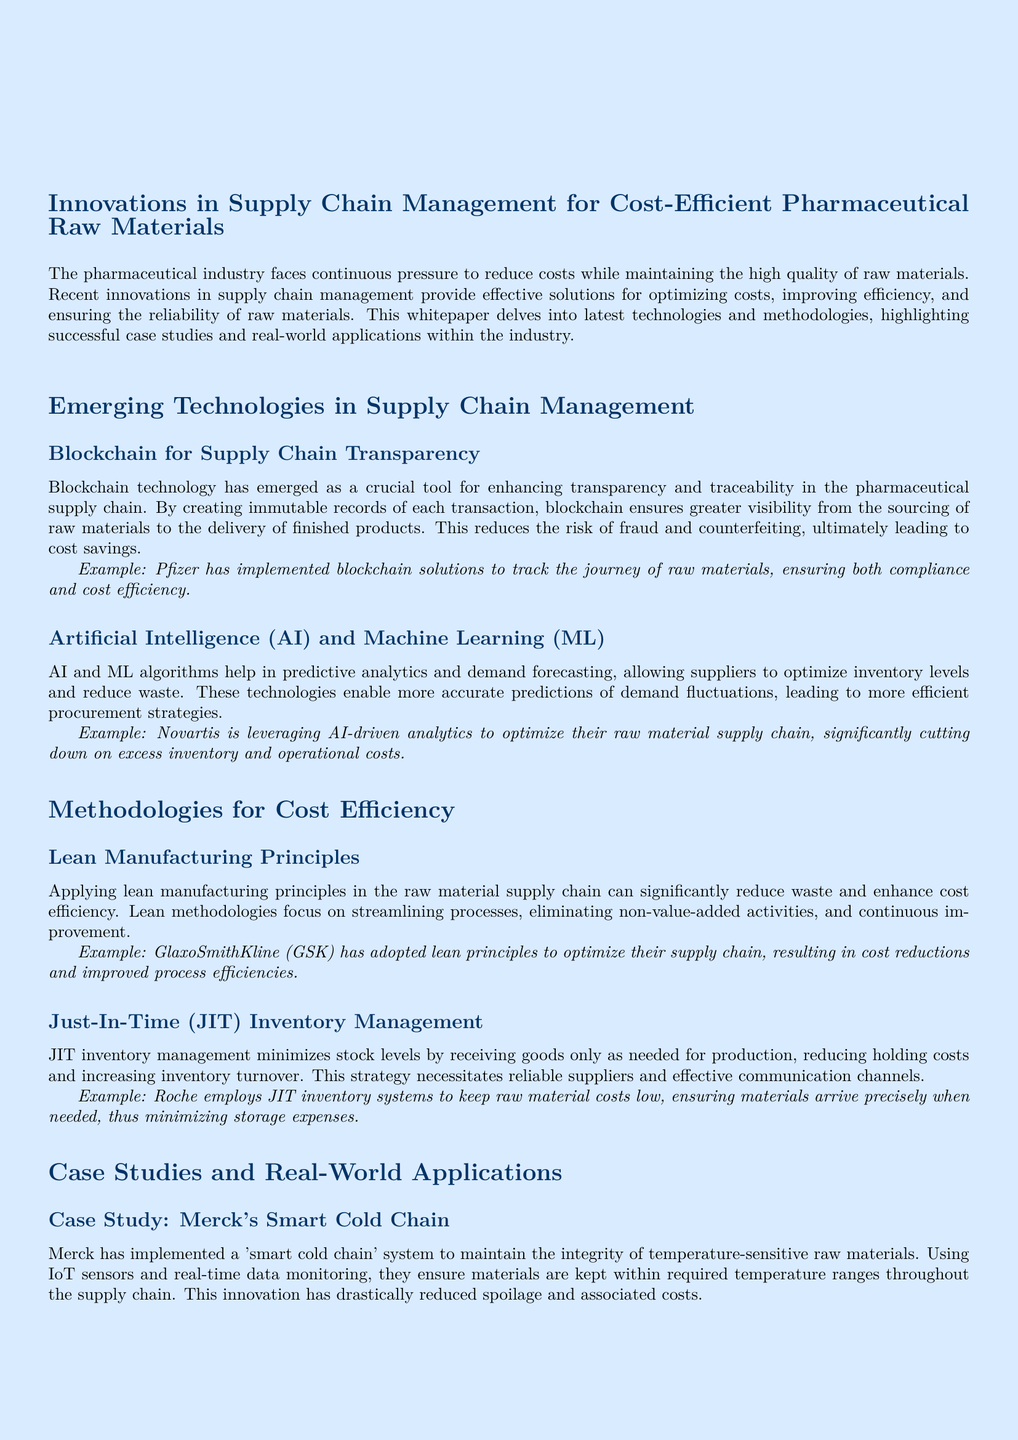What technology enhances supply chain transparency in pharmaceuticals? The document states that blockchain technology enhances supply chain transparency in pharmaceuticals by creating immutable records of each transaction.
Answer: Blockchain Which company uses AI-driven analytics to optimize their raw material supply chain? Novartis is mentioned as leveraging AI-driven analytics to optimize their raw material supply chain.
Answer: Novartis What inventory management strategy minimizes stock levels? Just-In-Time (JIT) inventory management is the strategy mentioned that minimizes stock levels.
Answer: Just-In-Time Which principle focuses on eliminating non-value-added activities? Lean manufacturing principles focus on eliminating non-value-added activities to enhance cost efficiency.
Answer: Lean manufacturing What is the name of Merck's system for temperature-sensitive raw materials? The system implemented by Merck for temperature-sensitive raw materials is referred to as 'smart cold chain.'
Answer: Smart cold chain Which company developed a digital collaboration platform for suppliers? Johnson & Johnson developed a digital collaboration platform to streamline interactions with their raw material suppliers.
Answer: Johnson & Johnson How does Roche keep raw material costs low? Roche employs JIT inventory systems to keep raw material costs low by ensuring materials arrive precisely when needed.
Answer: JIT inventory systems What result did GSK achieve by adopting lean principles? GSK achieved cost reductions and improved process efficiencies by adopting lean principles in their supply chain.
Answer: Cost reductions and improved process efficiencies 